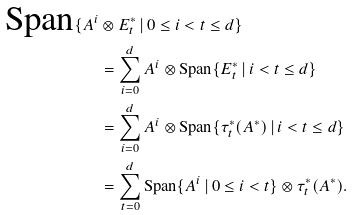<formula> <loc_0><loc_0><loc_500><loc_500>\text {Span} \{ A ^ { i } & \otimes E ^ { * } _ { t } \, | \, 0 \leq i < t \leq d \} \\ & = \sum _ { i = 0 } ^ { d } A ^ { i } \otimes \text {Span} \{ E ^ { * } _ { t } \, | \, i < t \leq d \} \\ & = \sum _ { i = 0 } ^ { d } A ^ { i } \otimes \text {Span} \{ \tau ^ { * } _ { t } ( A ^ { * } ) \, | \, i < t \leq d \} \\ & = \sum _ { t = 0 } ^ { d } \text {Span} \{ A ^ { i } \, | \, 0 \leq i < t \} \otimes \tau ^ { * } _ { t } ( A ^ { * } ) .</formula> 